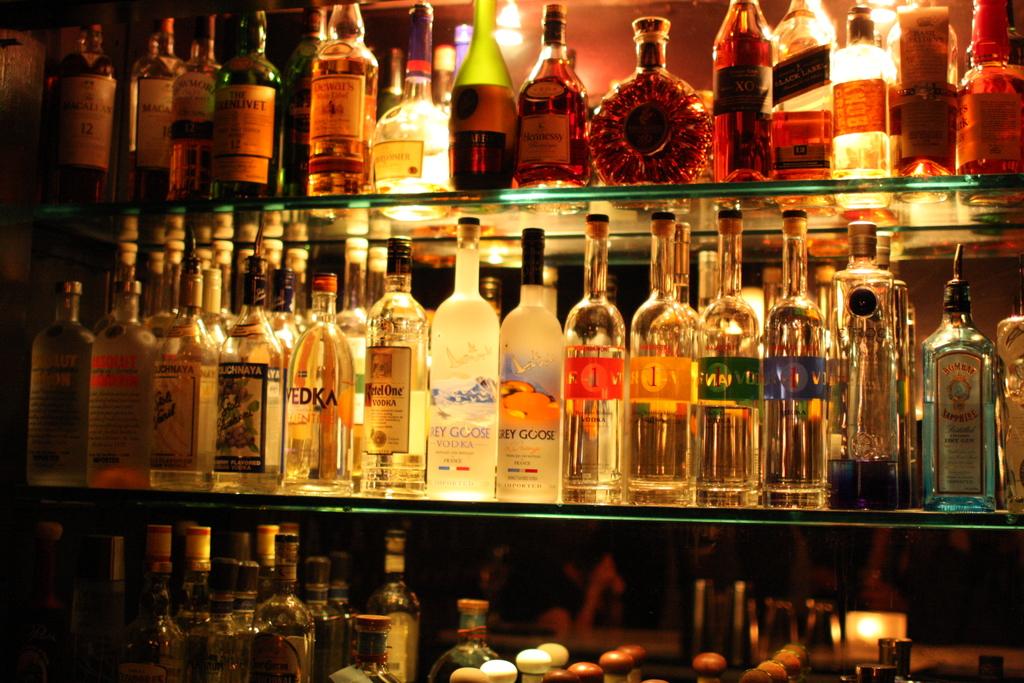What kind of vodka is on the shelf?
Make the answer very short. Grey goose. Is there more than one brand of vodka on the shelf?
Offer a very short reply. Yes. 